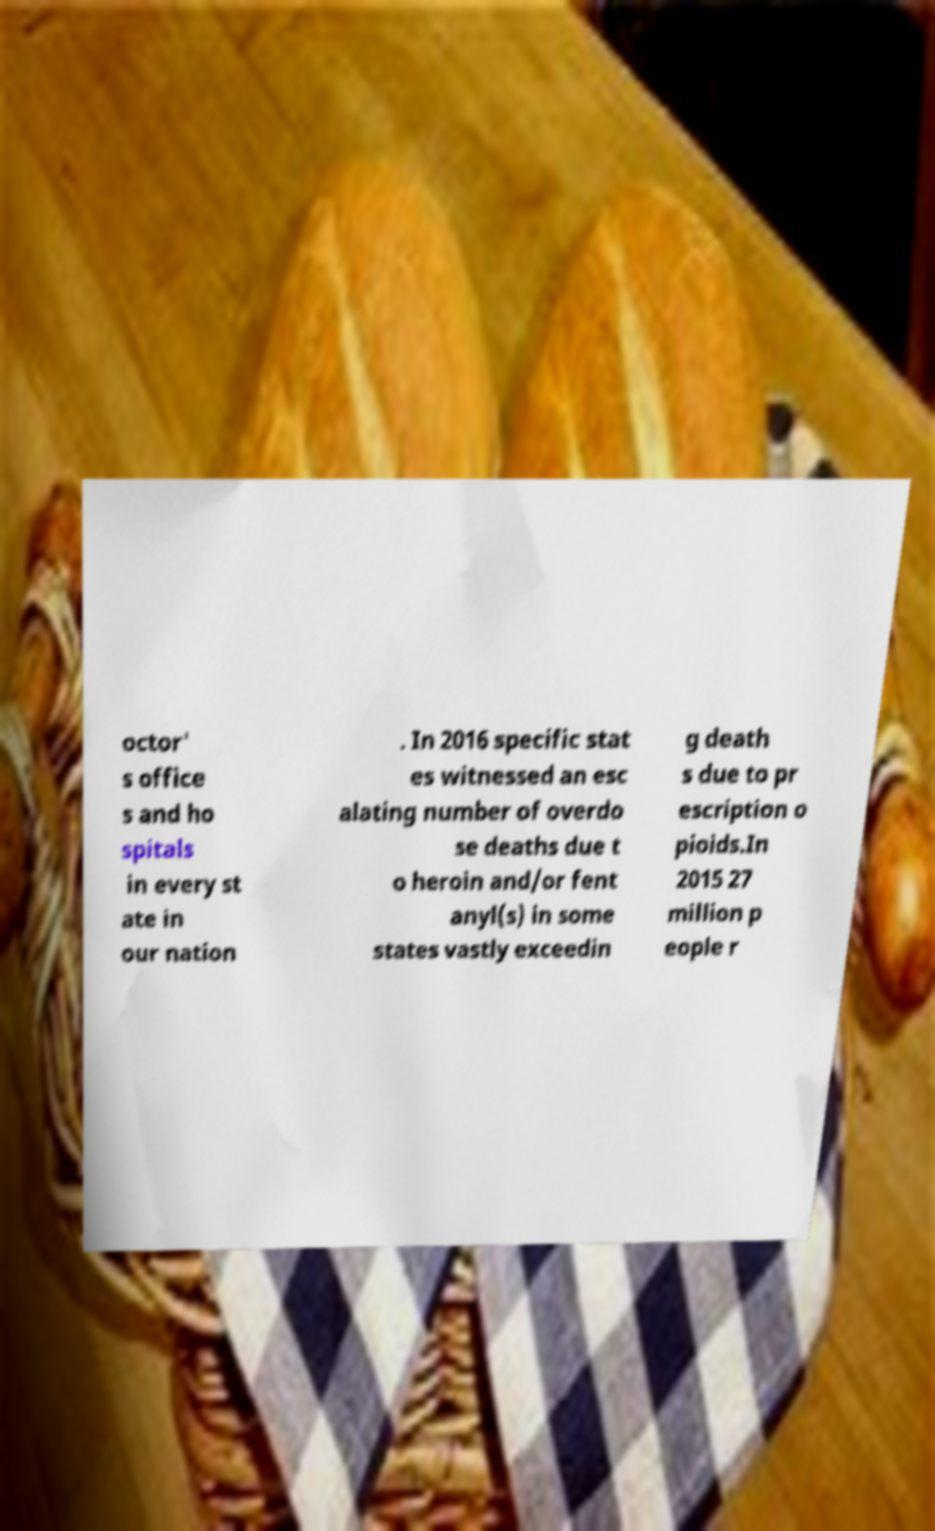Please identify and transcribe the text found in this image. octor' s office s and ho spitals in every st ate in our nation . In 2016 specific stat es witnessed an esc alating number of overdo se deaths due t o heroin and/or fent anyl(s) in some states vastly exceedin g death s due to pr escription o pioids.In 2015 27 million p eople r 